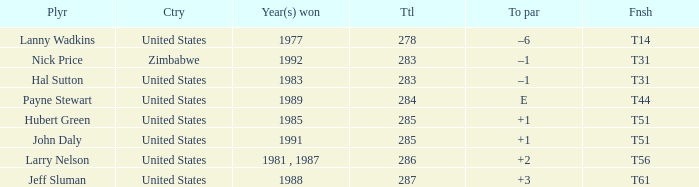What is Finish, when Year(s) Won is "1991"? T51. 